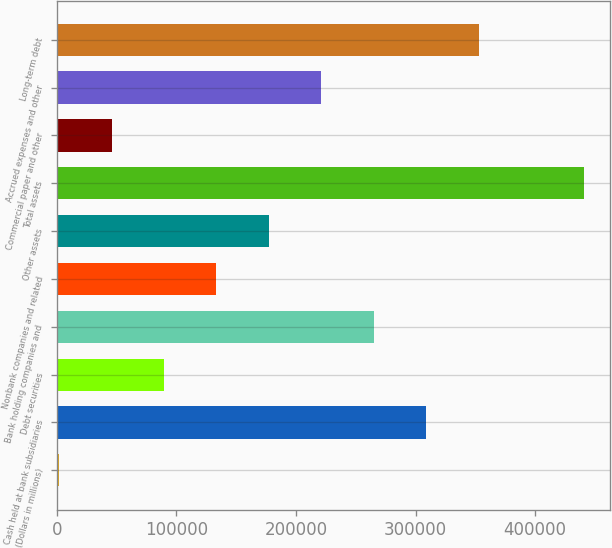Convert chart to OTSL. <chart><loc_0><loc_0><loc_500><loc_500><bar_chart><fcel>(Dollars in millions)<fcel>Cash held at bank subsidiaries<fcel>Debt securities<fcel>Bank holding companies and<fcel>Nonbank companies and related<fcel>Other assets<fcel>Total assets<fcel>Commercial paper and other<fcel>Accrued expenses and other<fcel>Long-term debt<nl><fcel>2009<fcel>308952<fcel>89707<fcel>265103<fcel>133556<fcel>177405<fcel>440499<fcel>45858<fcel>221254<fcel>352801<nl></chart> 